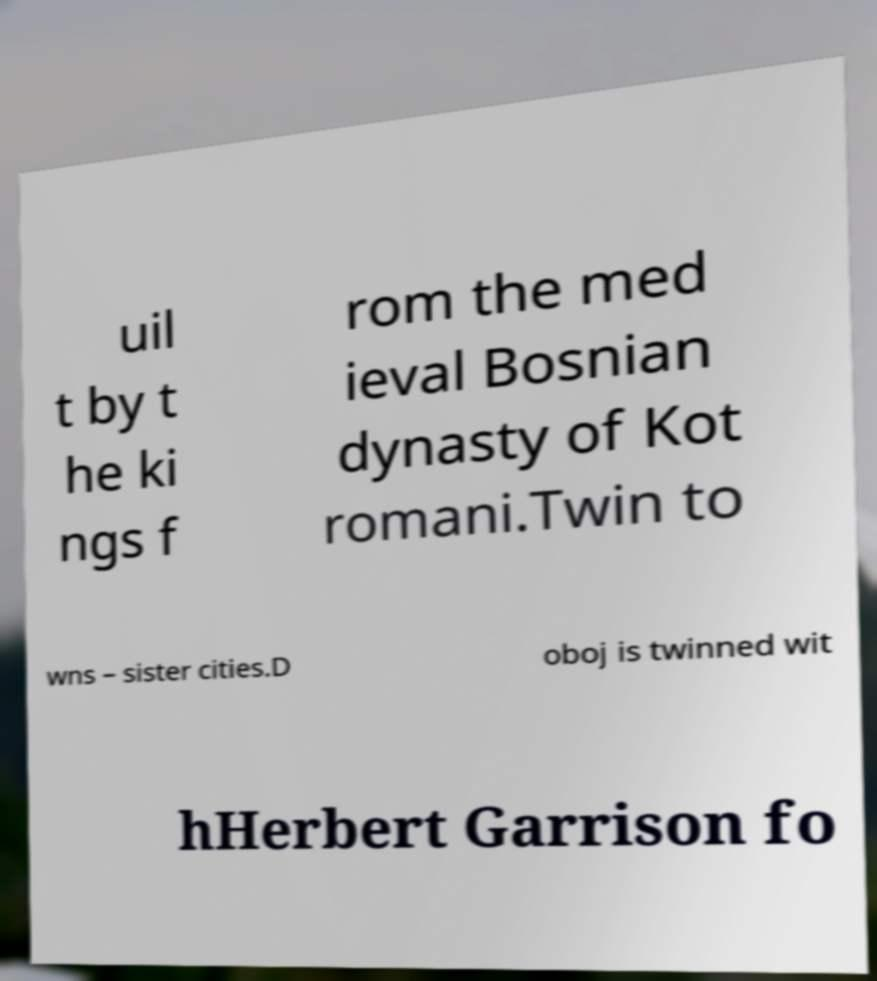I need the written content from this picture converted into text. Can you do that? uil t by t he ki ngs f rom the med ieval Bosnian dynasty of Kot romani.Twin to wns – sister cities.D oboj is twinned wit hHerbert Garrison fo 